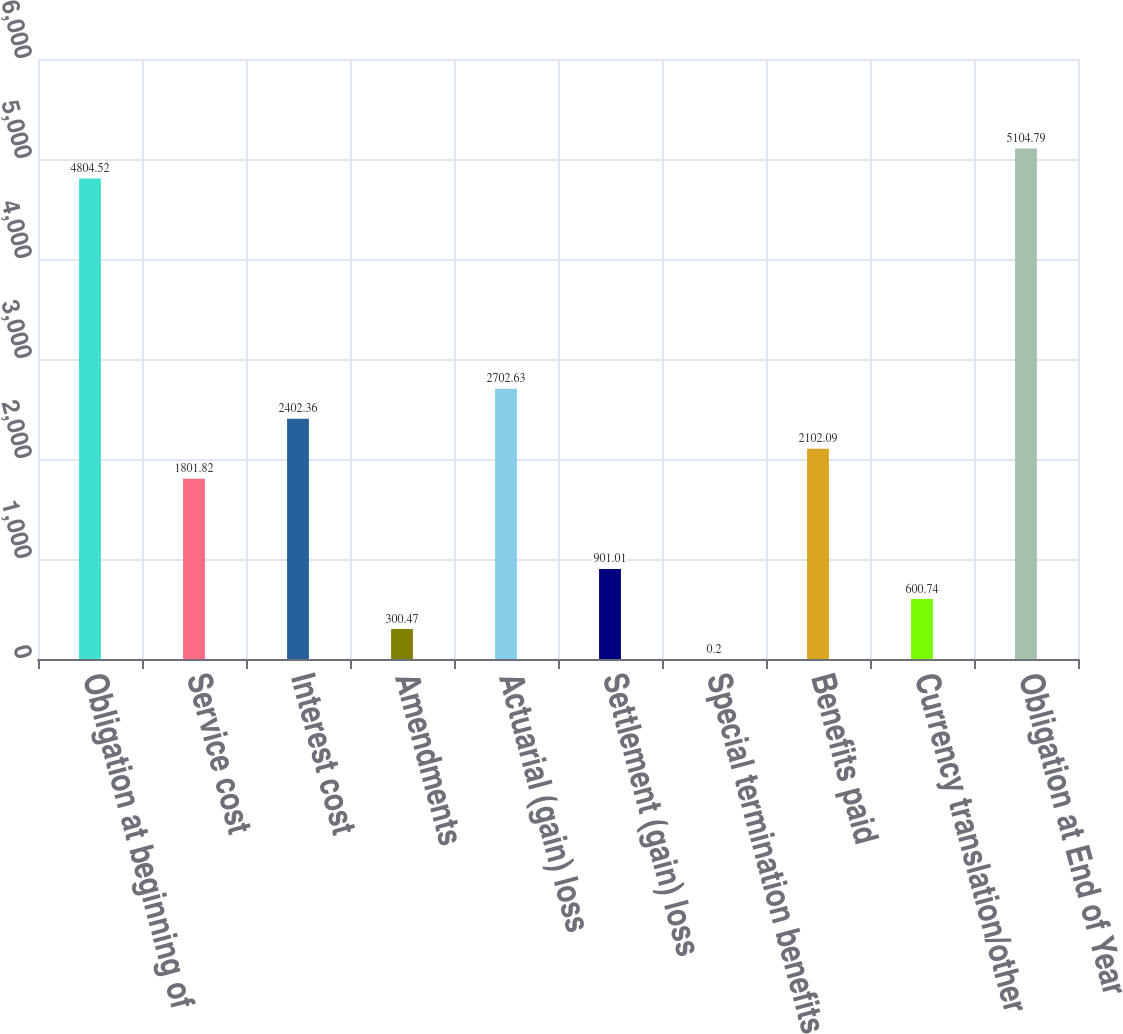Convert chart to OTSL. <chart><loc_0><loc_0><loc_500><loc_500><bar_chart><fcel>Obligation at beginning of<fcel>Service cost<fcel>Interest cost<fcel>Amendments<fcel>Actuarial (gain) loss<fcel>Settlement (gain) loss<fcel>Special termination benefits<fcel>Benefits paid<fcel>Currency translation/other<fcel>Obligation at End of Year<nl><fcel>4804.52<fcel>1801.82<fcel>2402.36<fcel>300.47<fcel>2702.63<fcel>901.01<fcel>0.2<fcel>2102.09<fcel>600.74<fcel>5104.79<nl></chart> 